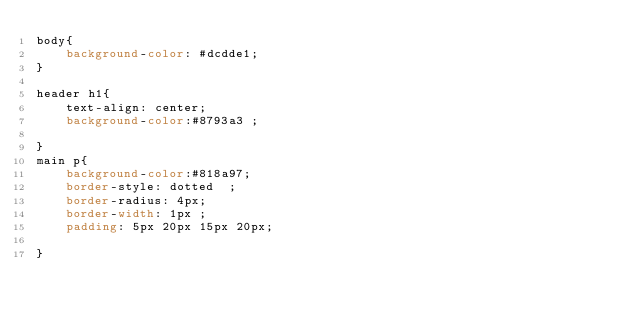<code> <loc_0><loc_0><loc_500><loc_500><_CSS_>body{
    background-color: #dcdde1;
}

header h1{
    text-align: center;
    background-color:#8793a3 ;
    
}
main p{
    background-color:#818a97;
    border-style: dotted  ;
    border-radius: 4px;
    border-width: 1px ;
    padding: 5px 20px 15px 20px;

}</code> 